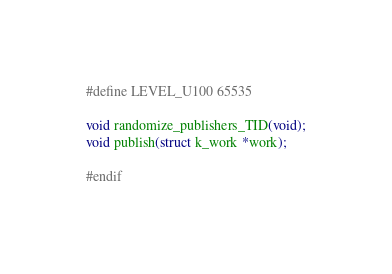Convert code to text. <code><loc_0><loc_0><loc_500><loc_500><_C_>#define LEVEL_U100 65535

void randomize_publishers_TID(void);
void publish(struct k_work *work);

#endif
</code> 